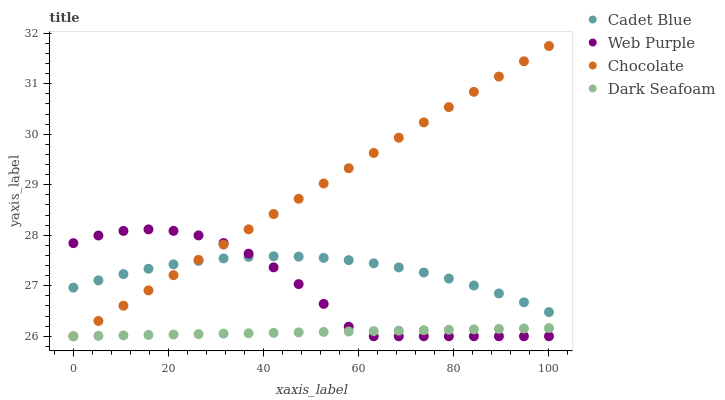Does Dark Seafoam have the minimum area under the curve?
Answer yes or no. Yes. Does Chocolate have the maximum area under the curve?
Answer yes or no. Yes. Does Cadet Blue have the minimum area under the curve?
Answer yes or no. No. Does Cadet Blue have the maximum area under the curve?
Answer yes or no. No. Is Dark Seafoam the smoothest?
Answer yes or no. Yes. Is Web Purple the roughest?
Answer yes or no. Yes. Is Cadet Blue the smoothest?
Answer yes or no. No. Is Cadet Blue the roughest?
Answer yes or no. No. Does Web Purple have the lowest value?
Answer yes or no. Yes. Does Cadet Blue have the lowest value?
Answer yes or no. No. Does Chocolate have the highest value?
Answer yes or no. Yes. Does Cadet Blue have the highest value?
Answer yes or no. No. Is Dark Seafoam less than Cadet Blue?
Answer yes or no. Yes. Is Cadet Blue greater than Dark Seafoam?
Answer yes or no. Yes. Does Chocolate intersect Dark Seafoam?
Answer yes or no. Yes. Is Chocolate less than Dark Seafoam?
Answer yes or no. No. Is Chocolate greater than Dark Seafoam?
Answer yes or no. No. Does Dark Seafoam intersect Cadet Blue?
Answer yes or no. No. 